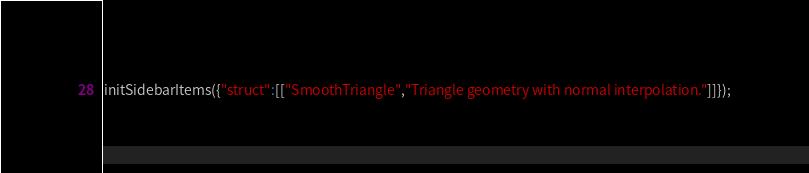Convert code to text. <code><loc_0><loc_0><loc_500><loc_500><_JavaScript_>initSidebarItems({"struct":[["SmoothTriangle","Triangle geometry with normal interpolation."]]});</code> 